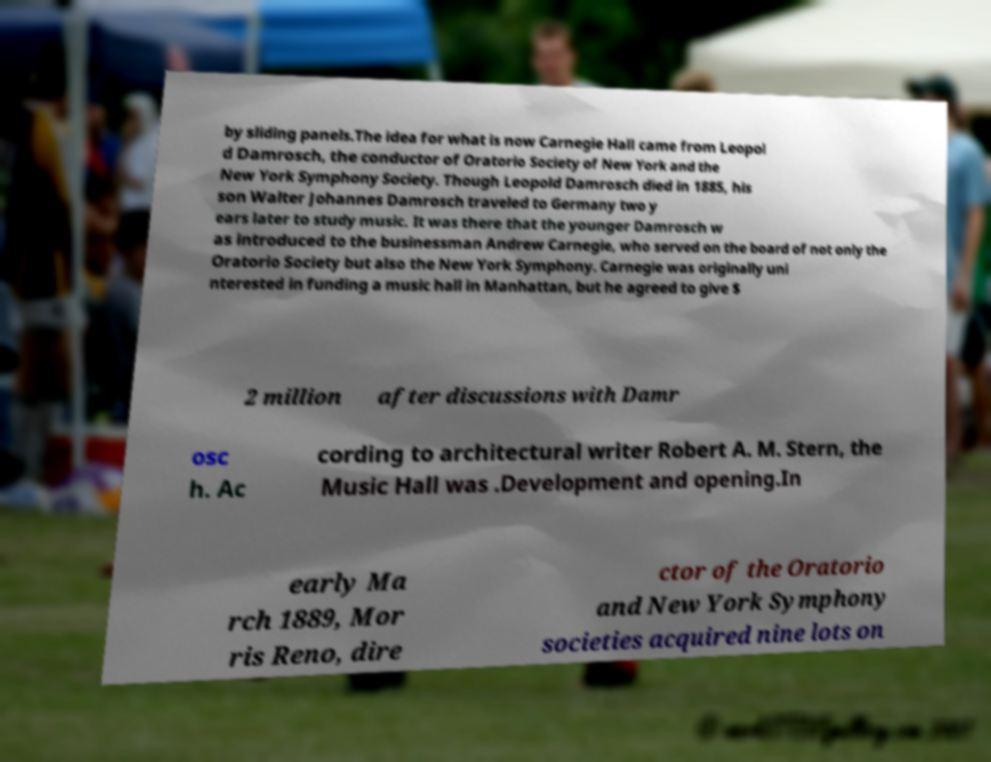There's text embedded in this image that I need extracted. Can you transcribe it verbatim? by sliding panels.The idea for what is now Carnegie Hall came from Leopol d Damrosch, the conductor of Oratorio Society of New York and the New York Symphony Society. Though Leopold Damrosch died in 1885, his son Walter Johannes Damrosch traveled to Germany two y ears later to study music. It was there that the younger Damrosch w as introduced to the businessman Andrew Carnegie, who served on the board of not only the Oratorio Society but also the New York Symphony. Carnegie was originally uni nterested in funding a music hall in Manhattan, but he agreed to give $ 2 million after discussions with Damr osc h. Ac cording to architectural writer Robert A. M. Stern, the Music Hall was .Development and opening.In early Ma rch 1889, Mor ris Reno, dire ctor of the Oratorio and New York Symphony societies acquired nine lots on 